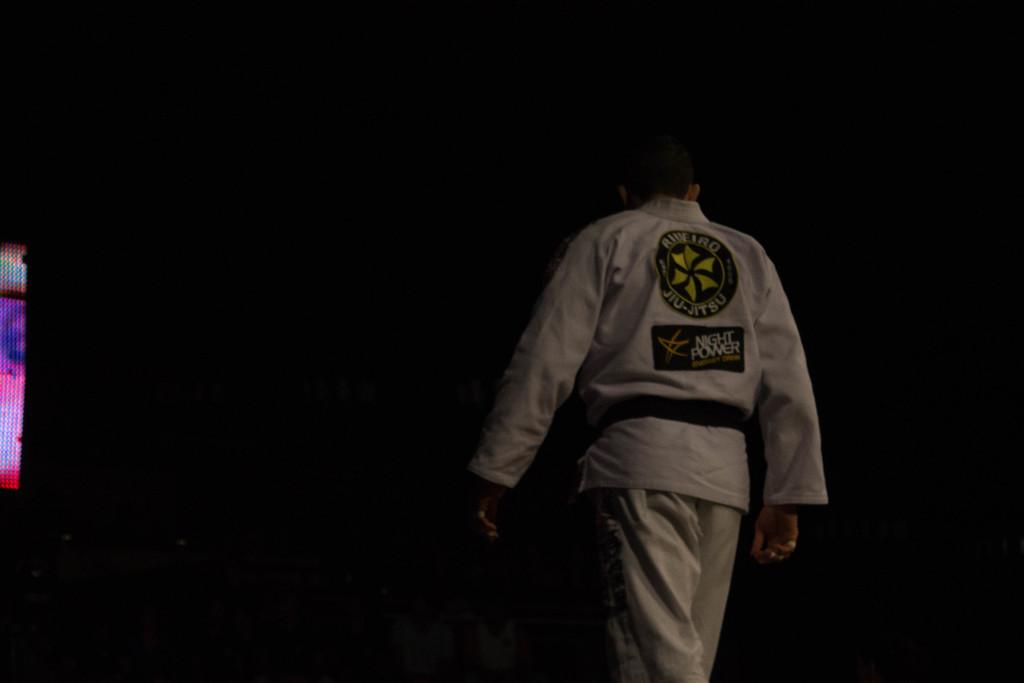What is the name of the sponsor at the bottom of this martial artist's shirt?
Keep it short and to the point. Night power. What type of martial art does this man practice?
Offer a terse response. Jiu-jitsu. 